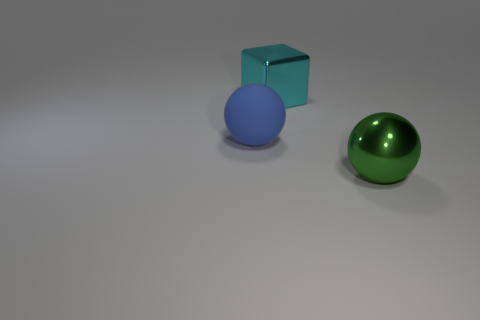Can you describe the objects in the image and their colors? Certainly! The image features three objects on a flat surface. On the left, there's a blue rubber ball, translucent in appearance. Just to its right, we see a small, solid blue cube, possibly metallic. On the right side of the image lies a larger, opaque green ball with a shiny, metallic surface. 